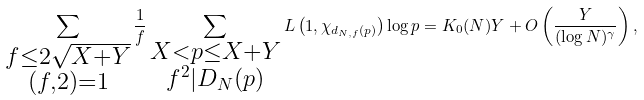Convert formula to latex. <formula><loc_0><loc_0><loc_500><loc_500>\sum _ { \substack { f \leq 2 \sqrt { X + Y } \\ ( f , 2 ) = 1 } } \frac { 1 } { f } \sum _ { \substack { X < p \leq X + Y \\ f ^ { 2 } | D _ { N } ( p ) } } L \left ( 1 , \chi _ { d _ { N , f } ( p ) } \right ) \log p = K _ { 0 } ( N ) Y + O \left ( \frac { Y } { ( \log { N } ) ^ { \gamma } } \right ) ,</formula> 